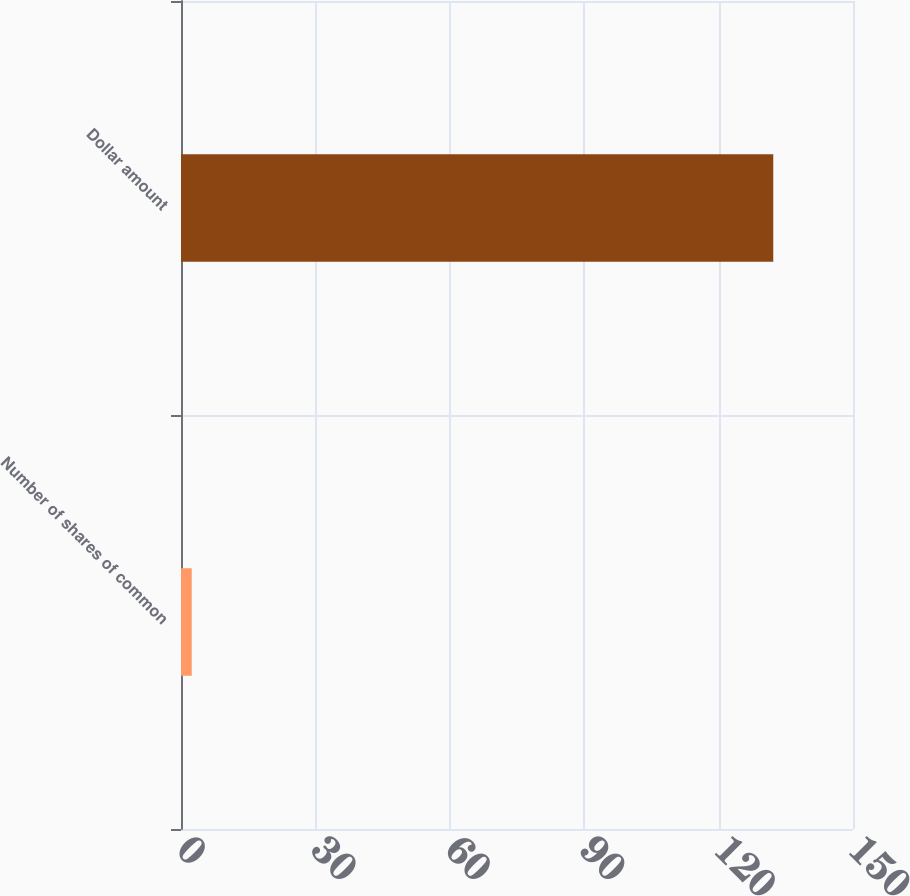<chart> <loc_0><loc_0><loc_500><loc_500><bar_chart><fcel>Number of shares of common<fcel>Dollar amount<nl><fcel>2.4<fcel>132.2<nl></chart> 